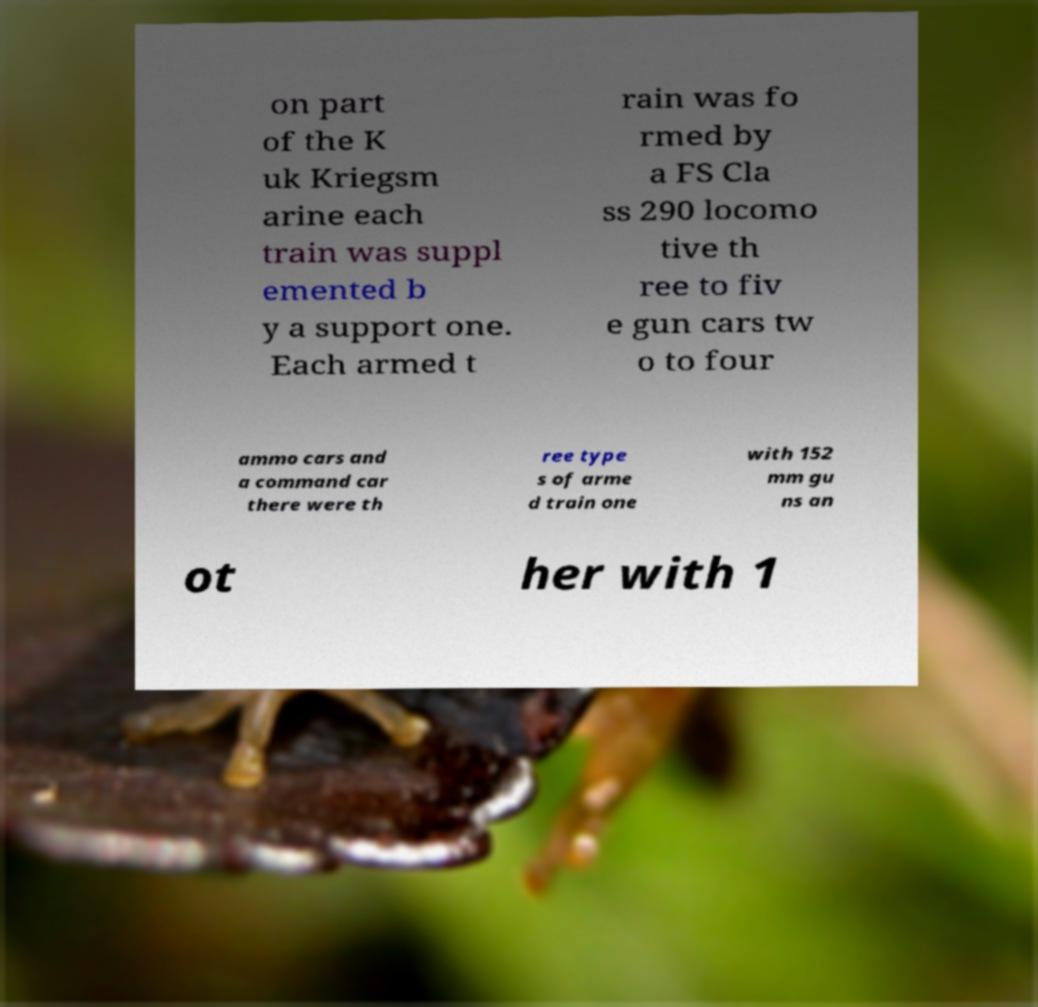Please identify and transcribe the text found in this image. on part of the K uk Kriegsm arine each train was suppl emented b y a support one. Each armed t rain was fo rmed by a FS Cla ss 290 locomo tive th ree to fiv e gun cars tw o to four ammo cars and a command car there were th ree type s of arme d train one with 152 mm gu ns an ot her with 1 